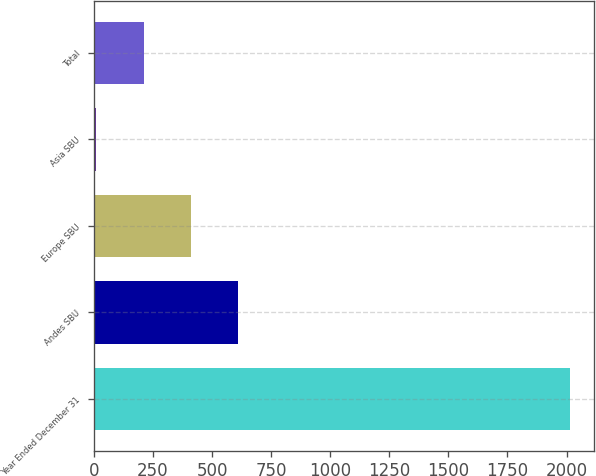<chart> <loc_0><loc_0><loc_500><loc_500><bar_chart><fcel>Year Ended December 31<fcel>Andes SBU<fcel>Europe SBU<fcel>Asia SBU<fcel>Total<nl><fcel>2014<fcel>611.2<fcel>410.8<fcel>10<fcel>210.4<nl></chart> 